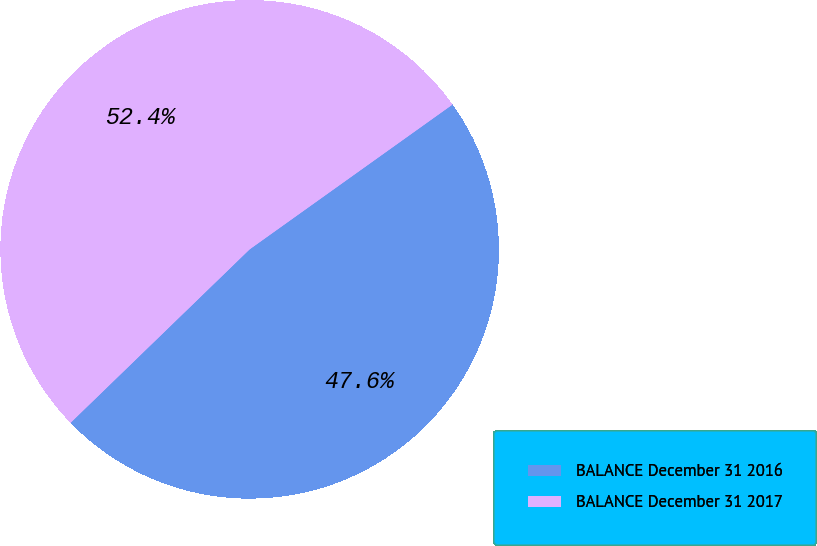Convert chart. <chart><loc_0><loc_0><loc_500><loc_500><pie_chart><fcel>BALANCE December 31 2016<fcel>BALANCE December 31 2017<nl><fcel>47.62%<fcel>52.38%<nl></chart> 